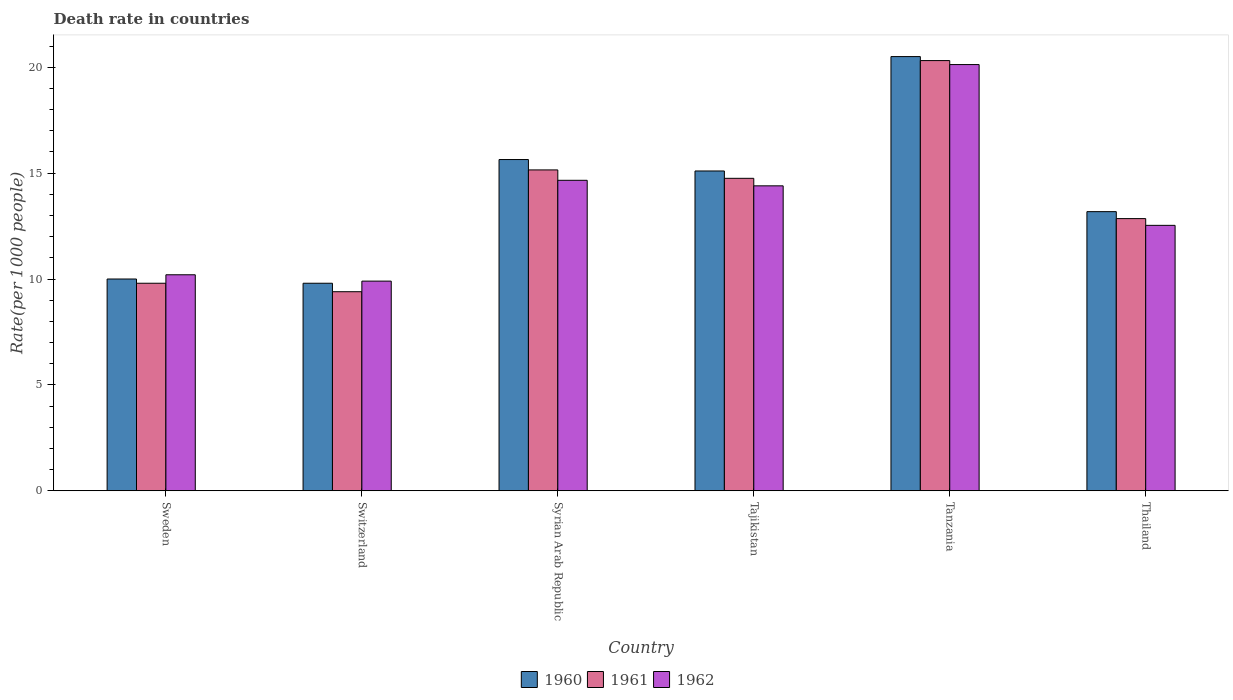Are the number of bars per tick equal to the number of legend labels?
Provide a succinct answer. Yes. Are the number of bars on each tick of the X-axis equal?
Provide a succinct answer. Yes. What is the label of the 2nd group of bars from the left?
Ensure brevity in your answer.  Switzerland. In how many cases, is the number of bars for a given country not equal to the number of legend labels?
Keep it short and to the point. 0. Across all countries, what is the maximum death rate in 1962?
Offer a terse response. 20.12. In which country was the death rate in 1962 maximum?
Your answer should be compact. Tanzania. In which country was the death rate in 1962 minimum?
Make the answer very short. Switzerland. What is the total death rate in 1960 in the graph?
Your answer should be compact. 84.22. What is the difference between the death rate in 1960 in Sweden and that in Thailand?
Keep it short and to the point. -3.18. What is the difference between the death rate in 1960 in Sweden and the death rate in 1961 in Switzerland?
Your answer should be very brief. 0.6. What is the average death rate in 1961 per country?
Make the answer very short. 13.71. What is the difference between the death rate of/in 1960 and death rate of/in 1962 in Syrian Arab Republic?
Your answer should be compact. 0.98. In how many countries, is the death rate in 1960 greater than 20?
Your answer should be very brief. 1. What is the ratio of the death rate in 1962 in Switzerland to that in Syrian Arab Republic?
Your response must be concise. 0.68. Is the death rate in 1960 in Switzerland less than that in Tanzania?
Ensure brevity in your answer.  Yes. Is the difference between the death rate in 1960 in Sweden and Tajikistan greater than the difference between the death rate in 1962 in Sweden and Tajikistan?
Provide a succinct answer. No. What is the difference between the highest and the second highest death rate in 1961?
Provide a succinct answer. 5.56. What is the difference between the highest and the lowest death rate in 1960?
Make the answer very short. 10.7. What does the 1st bar from the right in Tajikistan represents?
Provide a short and direct response. 1962. Is it the case that in every country, the sum of the death rate in 1960 and death rate in 1961 is greater than the death rate in 1962?
Make the answer very short. Yes. Are all the bars in the graph horizontal?
Offer a terse response. No. How many countries are there in the graph?
Keep it short and to the point. 6. How many legend labels are there?
Provide a short and direct response. 3. How are the legend labels stacked?
Ensure brevity in your answer.  Horizontal. What is the title of the graph?
Give a very brief answer. Death rate in countries. What is the label or title of the Y-axis?
Make the answer very short. Rate(per 1000 people). What is the Rate(per 1000 people) of 1960 in Sweden?
Keep it short and to the point. 10. What is the Rate(per 1000 people) of 1961 in Sweden?
Provide a short and direct response. 9.8. What is the Rate(per 1000 people) in 1961 in Switzerland?
Provide a succinct answer. 9.4. What is the Rate(per 1000 people) in 1962 in Switzerland?
Your response must be concise. 9.9. What is the Rate(per 1000 people) of 1960 in Syrian Arab Republic?
Provide a succinct answer. 15.64. What is the Rate(per 1000 people) in 1961 in Syrian Arab Republic?
Your answer should be very brief. 15.15. What is the Rate(per 1000 people) in 1962 in Syrian Arab Republic?
Keep it short and to the point. 14.66. What is the Rate(per 1000 people) in 1960 in Tajikistan?
Ensure brevity in your answer.  15.1. What is the Rate(per 1000 people) in 1961 in Tajikistan?
Keep it short and to the point. 14.75. What is the Rate(per 1000 people) of 1962 in Tajikistan?
Provide a succinct answer. 14.4. What is the Rate(per 1000 people) in 1960 in Tanzania?
Provide a short and direct response. 20.5. What is the Rate(per 1000 people) in 1961 in Tanzania?
Offer a very short reply. 20.31. What is the Rate(per 1000 people) in 1962 in Tanzania?
Give a very brief answer. 20.12. What is the Rate(per 1000 people) in 1960 in Thailand?
Make the answer very short. 13.18. What is the Rate(per 1000 people) in 1961 in Thailand?
Give a very brief answer. 12.85. What is the Rate(per 1000 people) in 1962 in Thailand?
Your response must be concise. 12.53. Across all countries, what is the maximum Rate(per 1000 people) of 1960?
Offer a terse response. 20.5. Across all countries, what is the maximum Rate(per 1000 people) in 1961?
Your response must be concise. 20.31. Across all countries, what is the maximum Rate(per 1000 people) in 1962?
Provide a succinct answer. 20.12. What is the total Rate(per 1000 people) of 1960 in the graph?
Your answer should be very brief. 84.22. What is the total Rate(per 1000 people) in 1961 in the graph?
Offer a very short reply. 82.27. What is the total Rate(per 1000 people) of 1962 in the graph?
Your response must be concise. 81.82. What is the difference between the Rate(per 1000 people) in 1961 in Sweden and that in Switzerland?
Keep it short and to the point. 0.4. What is the difference between the Rate(per 1000 people) of 1960 in Sweden and that in Syrian Arab Republic?
Give a very brief answer. -5.64. What is the difference between the Rate(per 1000 people) of 1961 in Sweden and that in Syrian Arab Republic?
Offer a very short reply. -5.35. What is the difference between the Rate(per 1000 people) of 1962 in Sweden and that in Syrian Arab Republic?
Provide a succinct answer. -4.46. What is the difference between the Rate(per 1000 people) in 1960 in Sweden and that in Tajikistan?
Your answer should be compact. -5.1. What is the difference between the Rate(per 1000 people) in 1961 in Sweden and that in Tajikistan?
Offer a very short reply. -4.95. What is the difference between the Rate(per 1000 people) in 1962 in Sweden and that in Tajikistan?
Keep it short and to the point. -4.2. What is the difference between the Rate(per 1000 people) of 1960 in Sweden and that in Tanzania?
Give a very brief answer. -10.5. What is the difference between the Rate(per 1000 people) in 1961 in Sweden and that in Tanzania?
Give a very brief answer. -10.51. What is the difference between the Rate(per 1000 people) in 1962 in Sweden and that in Tanzania?
Make the answer very short. -9.93. What is the difference between the Rate(per 1000 people) of 1960 in Sweden and that in Thailand?
Your answer should be very brief. -3.18. What is the difference between the Rate(per 1000 people) of 1961 in Sweden and that in Thailand?
Your answer should be compact. -3.05. What is the difference between the Rate(per 1000 people) in 1962 in Sweden and that in Thailand?
Your answer should be very brief. -2.33. What is the difference between the Rate(per 1000 people) of 1960 in Switzerland and that in Syrian Arab Republic?
Ensure brevity in your answer.  -5.84. What is the difference between the Rate(per 1000 people) of 1961 in Switzerland and that in Syrian Arab Republic?
Your answer should be very brief. -5.75. What is the difference between the Rate(per 1000 people) in 1962 in Switzerland and that in Syrian Arab Republic?
Your response must be concise. -4.76. What is the difference between the Rate(per 1000 people) in 1960 in Switzerland and that in Tajikistan?
Offer a terse response. -5.3. What is the difference between the Rate(per 1000 people) in 1961 in Switzerland and that in Tajikistan?
Ensure brevity in your answer.  -5.35. What is the difference between the Rate(per 1000 people) in 1962 in Switzerland and that in Tajikistan?
Your answer should be very brief. -4.5. What is the difference between the Rate(per 1000 people) in 1960 in Switzerland and that in Tanzania?
Offer a very short reply. -10.7. What is the difference between the Rate(per 1000 people) in 1961 in Switzerland and that in Tanzania?
Keep it short and to the point. -10.91. What is the difference between the Rate(per 1000 people) of 1962 in Switzerland and that in Tanzania?
Offer a terse response. -10.22. What is the difference between the Rate(per 1000 people) of 1960 in Switzerland and that in Thailand?
Give a very brief answer. -3.38. What is the difference between the Rate(per 1000 people) of 1961 in Switzerland and that in Thailand?
Give a very brief answer. -3.45. What is the difference between the Rate(per 1000 people) in 1962 in Switzerland and that in Thailand?
Make the answer very short. -2.63. What is the difference between the Rate(per 1000 people) in 1960 in Syrian Arab Republic and that in Tajikistan?
Provide a succinct answer. 0.54. What is the difference between the Rate(per 1000 people) in 1961 in Syrian Arab Republic and that in Tajikistan?
Your answer should be compact. 0.4. What is the difference between the Rate(per 1000 people) of 1962 in Syrian Arab Republic and that in Tajikistan?
Keep it short and to the point. 0.26. What is the difference between the Rate(per 1000 people) in 1960 in Syrian Arab Republic and that in Tanzania?
Your answer should be very brief. -4.86. What is the difference between the Rate(per 1000 people) in 1961 in Syrian Arab Republic and that in Tanzania?
Offer a terse response. -5.16. What is the difference between the Rate(per 1000 people) in 1962 in Syrian Arab Republic and that in Tanzania?
Your answer should be very brief. -5.46. What is the difference between the Rate(per 1000 people) of 1960 in Syrian Arab Republic and that in Thailand?
Offer a very short reply. 2.46. What is the difference between the Rate(per 1000 people) in 1961 in Syrian Arab Republic and that in Thailand?
Provide a short and direct response. 2.3. What is the difference between the Rate(per 1000 people) in 1962 in Syrian Arab Republic and that in Thailand?
Ensure brevity in your answer.  2.13. What is the difference between the Rate(per 1000 people) of 1960 in Tajikistan and that in Tanzania?
Ensure brevity in your answer.  -5.4. What is the difference between the Rate(per 1000 people) in 1961 in Tajikistan and that in Tanzania?
Offer a very short reply. -5.56. What is the difference between the Rate(per 1000 people) in 1962 in Tajikistan and that in Tanzania?
Your answer should be very brief. -5.73. What is the difference between the Rate(per 1000 people) of 1960 in Tajikistan and that in Thailand?
Provide a succinct answer. 1.92. What is the difference between the Rate(per 1000 people) in 1961 in Tajikistan and that in Thailand?
Offer a very short reply. 1.9. What is the difference between the Rate(per 1000 people) in 1962 in Tajikistan and that in Thailand?
Your answer should be compact. 1.87. What is the difference between the Rate(per 1000 people) of 1960 in Tanzania and that in Thailand?
Make the answer very short. 7.32. What is the difference between the Rate(per 1000 people) of 1961 in Tanzania and that in Thailand?
Make the answer very short. 7.46. What is the difference between the Rate(per 1000 people) of 1962 in Tanzania and that in Thailand?
Offer a very short reply. 7.59. What is the difference between the Rate(per 1000 people) of 1961 in Sweden and the Rate(per 1000 people) of 1962 in Switzerland?
Make the answer very short. -0.1. What is the difference between the Rate(per 1000 people) of 1960 in Sweden and the Rate(per 1000 people) of 1961 in Syrian Arab Republic?
Ensure brevity in your answer.  -5.15. What is the difference between the Rate(per 1000 people) of 1960 in Sweden and the Rate(per 1000 people) of 1962 in Syrian Arab Republic?
Offer a terse response. -4.66. What is the difference between the Rate(per 1000 people) of 1961 in Sweden and the Rate(per 1000 people) of 1962 in Syrian Arab Republic?
Your response must be concise. -4.86. What is the difference between the Rate(per 1000 people) in 1960 in Sweden and the Rate(per 1000 people) in 1961 in Tajikistan?
Make the answer very short. -4.75. What is the difference between the Rate(per 1000 people) of 1960 in Sweden and the Rate(per 1000 people) of 1962 in Tajikistan?
Provide a succinct answer. -4.4. What is the difference between the Rate(per 1000 people) of 1961 in Sweden and the Rate(per 1000 people) of 1962 in Tajikistan?
Give a very brief answer. -4.6. What is the difference between the Rate(per 1000 people) of 1960 in Sweden and the Rate(per 1000 people) of 1961 in Tanzania?
Keep it short and to the point. -10.31. What is the difference between the Rate(per 1000 people) of 1960 in Sweden and the Rate(per 1000 people) of 1962 in Tanzania?
Ensure brevity in your answer.  -10.12. What is the difference between the Rate(per 1000 people) in 1961 in Sweden and the Rate(per 1000 people) in 1962 in Tanzania?
Give a very brief answer. -10.32. What is the difference between the Rate(per 1000 people) of 1960 in Sweden and the Rate(per 1000 people) of 1961 in Thailand?
Provide a succinct answer. -2.85. What is the difference between the Rate(per 1000 people) in 1960 in Sweden and the Rate(per 1000 people) in 1962 in Thailand?
Offer a very short reply. -2.53. What is the difference between the Rate(per 1000 people) of 1961 in Sweden and the Rate(per 1000 people) of 1962 in Thailand?
Your answer should be compact. -2.73. What is the difference between the Rate(per 1000 people) in 1960 in Switzerland and the Rate(per 1000 people) in 1961 in Syrian Arab Republic?
Your response must be concise. -5.35. What is the difference between the Rate(per 1000 people) of 1960 in Switzerland and the Rate(per 1000 people) of 1962 in Syrian Arab Republic?
Your answer should be compact. -4.86. What is the difference between the Rate(per 1000 people) of 1961 in Switzerland and the Rate(per 1000 people) of 1962 in Syrian Arab Republic?
Make the answer very short. -5.26. What is the difference between the Rate(per 1000 people) of 1960 in Switzerland and the Rate(per 1000 people) of 1961 in Tajikistan?
Your response must be concise. -4.95. What is the difference between the Rate(per 1000 people) of 1960 in Switzerland and the Rate(per 1000 people) of 1962 in Tajikistan?
Give a very brief answer. -4.6. What is the difference between the Rate(per 1000 people) of 1961 in Switzerland and the Rate(per 1000 people) of 1962 in Tajikistan?
Offer a terse response. -5. What is the difference between the Rate(per 1000 people) in 1960 in Switzerland and the Rate(per 1000 people) in 1961 in Tanzania?
Your response must be concise. -10.51. What is the difference between the Rate(per 1000 people) of 1960 in Switzerland and the Rate(per 1000 people) of 1962 in Tanzania?
Ensure brevity in your answer.  -10.32. What is the difference between the Rate(per 1000 people) in 1961 in Switzerland and the Rate(per 1000 people) in 1962 in Tanzania?
Offer a terse response. -10.72. What is the difference between the Rate(per 1000 people) in 1960 in Switzerland and the Rate(per 1000 people) in 1961 in Thailand?
Offer a terse response. -3.05. What is the difference between the Rate(per 1000 people) in 1960 in Switzerland and the Rate(per 1000 people) in 1962 in Thailand?
Provide a short and direct response. -2.73. What is the difference between the Rate(per 1000 people) in 1961 in Switzerland and the Rate(per 1000 people) in 1962 in Thailand?
Keep it short and to the point. -3.13. What is the difference between the Rate(per 1000 people) of 1960 in Syrian Arab Republic and the Rate(per 1000 people) of 1961 in Tajikistan?
Give a very brief answer. 0.89. What is the difference between the Rate(per 1000 people) in 1960 in Syrian Arab Republic and the Rate(per 1000 people) in 1962 in Tajikistan?
Make the answer very short. 1.24. What is the difference between the Rate(per 1000 people) of 1961 in Syrian Arab Republic and the Rate(per 1000 people) of 1962 in Tajikistan?
Ensure brevity in your answer.  0.75. What is the difference between the Rate(per 1000 people) of 1960 in Syrian Arab Republic and the Rate(per 1000 people) of 1961 in Tanzania?
Keep it short and to the point. -4.67. What is the difference between the Rate(per 1000 people) of 1960 in Syrian Arab Republic and the Rate(per 1000 people) of 1962 in Tanzania?
Provide a succinct answer. -4.48. What is the difference between the Rate(per 1000 people) in 1961 in Syrian Arab Republic and the Rate(per 1000 people) in 1962 in Tanzania?
Offer a terse response. -4.97. What is the difference between the Rate(per 1000 people) of 1960 in Syrian Arab Republic and the Rate(per 1000 people) of 1961 in Thailand?
Your answer should be compact. 2.79. What is the difference between the Rate(per 1000 people) of 1960 in Syrian Arab Republic and the Rate(per 1000 people) of 1962 in Thailand?
Keep it short and to the point. 3.11. What is the difference between the Rate(per 1000 people) of 1961 in Syrian Arab Republic and the Rate(per 1000 people) of 1962 in Thailand?
Your response must be concise. 2.62. What is the difference between the Rate(per 1000 people) of 1960 in Tajikistan and the Rate(per 1000 people) of 1961 in Tanzania?
Give a very brief answer. -5.21. What is the difference between the Rate(per 1000 people) in 1960 in Tajikistan and the Rate(per 1000 people) in 1962 in Tanzania?
Provide a succinct answer. -5.02. What is the difference between the Rate(per 1000 people) of 1961 in Tajikistan and the Rate(per 1000 people) of 1962 in Tanzania?
Your answer should be very brief. -5.37. What is the difference between the Rate(per 1000 people) in 1960 in Tajikistan and the Rate(per 1000 people) in 1961 in Thailand?
Your answer should be compact. 2.25. What is the difference between the Rate(per 1000 people) of 1960 in Tajikistan and the Rate(per 1000 people) of 1962 in Thailand?
Give a very brief answer. 2.57. What is the difference between the Rate(per 1000 people) in 1961 in Tajikistan and the Rate(per 1000 people) in 1962 in Thailand?
Give a very brief answer. 2.22. What is the difference between the Rate(per 1000 people) in 1960 in Tanzania and the Rate(per 1000 people) in 1961 in Thailand?
Provide a succinct answer. 7.65. What is the difference between the Rate(per 1000 people) of 1960 in Tanzania and the Rate(per 1000 people) of 1962 in Thailand?
Your answer should be very brief. 7.97. What is the difference between the Rate(per 1000 people) in 1961 in Tanzania and the Rate(per 1000 people) in 1962 in Thailand?
Ensure brevity in your answer.  7.78. What is the average Rate(per 1000 people) of 1960 per country?
Keep it short and to the point. 14.04. What is the average Rate(per 1000 people) in 1961 per country?
Provide a short and direct response. 13.71. What is the average Rate(per 1000 people) in 1962 per country?
Provide a short and direct response. 13.64. What is the difference between the Rate(per 1000 people) of 1960 and Rate(per 1000 people) of 1961 in Sweden?
Ensure brevity in your answer.  0.2. What is the difference between the Rate(per 1000 people) in 1961 and Rate(per 1000 people) in 1962 in Sweden?
Keep it short and to the point. -0.4. What is the difference between the Rate(per 1000 people) in 1960 and Rate(per 1000 people) in 1962 in Switzerland?
Your answer should be very brief. -0.1. What is the difference between the Rate(per 1000 people) of 1961 and Rate(per 1000 people) of 1962 in Switzerland?
Ensure brevity in your answer.  -0.5. What is the difference between the Rate(per 1000 people) of 1960 and Rate(per 1000 people) of 1961 in Syrian Arab Republic?
Give a very brief answer. 0.49. What is the difference between the Rate(per 1000 people) in 1960 and Rate(per 1000 people) in 1962 in Syrian Arab Republic?
Offer a very short reply. 0.98. What is the difference between the Rate(per 1000 people) of 1961 and Rate(per 1000 people) of 1962 in Syrian Arab Republic?
Your answer should be very brief. 0.49. What is the difference between the Rate(per 1000 people) in 1960 and Rate(per 1000 people) in 1961 in Tajikistan?
Provide a succinct answer. 0.35. What is the difference between the Rate(per 1000 people) of 1960 and Rate(per 1000 people) of 1962 in Tajikistan?
Your answer should be very brief. 0.7. What is the difference between the Rate(per 1000 people) in 1961 and Rate(per 1000 people) in 1962 in Tajikistan?
Give a very brief answer. 0.35. What is the difference between the Rate(per 1000 people) of 1960 and Rate(per 1000 people) of 1961 in Tanzania?
Make the answer very short. 0.19. What is the difference between the Rate(per 1000 people) of 1960 and Rate(per 1000 people) of 1962 in Tanzania?
Your answer should be compact. 0.38. What is the difference between the Rate(per 1000 people) of 1961 and Rate(per 1000 people) of 1962 in Tanzania?
Give a very brief answer. 0.19. What is the difference between the Rate(per 1000 people) in 1960 and Rate(per 1000 people) in 1961 in Thailand?
Offer a terse response. 0.33. What is the difference between the Rate(per 1000 people) in 1960 and Rate(per 1000 people) in 1962 in Thailand?
Keep it short and to the point. 0.65. What is the difference between the Rate(per 1000 people) in 1961 and Rate(per 1000 people) in 1962 in Thailand?
Your response must be concise. 0.32. What is the ratio of the Rate(per 1000 people) of 1960 in Sweden to that in Switzerland?
Keep it short and to the point. 1.02. What is the ratio of the Rate(per 1000 people) in 1961 in Sweden to that in Switzerland?
Offer a terse response. 1.04. What is the ratio of the Rate(per 1000 people) in 1962 in Sweden to that in Switzerland?
Keep it short and to the point. 1.03. What is the ratio of the Rate(per 1000 people) in 1960 in Sweden to that in Syrian Arab Republic?
Provide a succinct answer. 0.64. What is the ratio of the Rate(per 1000 people) of 1961 in Sweden to that in Syrian Arab Republic?
Give a very brief answer. 0.65. What is the ratio of the Rate(per 1000 people) of 1962 in Sweden to that in Syrian Arab Republic?
Offer a terse response. 0.7. What is the ratio of the Rate(per 1000 people) of 1960 in Sweden to that in Tajikistan?
Offer a very short reply. 0.66. What is the ratio of the Rate(per 1000 people) in 1961 in Sweden to that in Tajikistan?
Ensure brevity in your answer.  0.66. What is the ratio of the Rate(per 1000 people) of 1962 in Sweden to that in Tajikistan?
Make the answer very short. 0.71. What is the ratio of the Rate(per 1000 people) in 1960 in Sweden to that in Tanzania?
Your answer should be very brief. 0.49. What is the ratio of the Rate(per 1000 people) of 1961 in Sweden to that in Tanzania?
Make the answer very short. 0.48. What is the ratio of the Rate(per 1000 people) of 1962 in Sweden to that in Tanzania?
Provide a succinct answer. 0.51. What is the ratio of the Rate(per 1000 people) of 1960 in Sweden to that in Thailand?
Your answer should be compact. 0.76. What is the ratio of the Rate(per 1000 people) in 1961 in Sweden to that in Thailand?
Provide a succinct answer. 0.76. What is the ratio of the Rate(per 1000 people) in 1962 in Sweden to that in Thailand?
Make the answer very short. 0.81. What is the ratio of the Rate(per 1000 people) of 1960 in Switzerland to that in Syrian Arab Republic?
Make the answer very short. 0.63. What is the ratio of the Rate(per 1000 people) of 1961 in Switzerland to that in Syrian Arab Republic?
Your answer should be very brief. 0.62. What is the ratio of the Rate(per 1000 people) of 1962 in Switzerland to that in Syrian Arab Republic?
Your answer should be very brief. 0.68. What is the ratio of the Rate(per 1000 people) in 1960 in Switzerland to that in Tajikistan?
Offer a terse response. 0.65. What is the ratio of the Rate(per 1000 people) of 1961 in Switzerland to that in Tajikistan?
Your answer should be compact. 0.64. What is the ratio of the Rate(per 1000 people) of 1962 in Switzerland to that in Tajikistan?
Provide a succinct answer. 0.69. What is the ratio of the Rate(per 1000 people) in 1960 in Switzerland to that in Tanzania?
Offer a very short reply. 0.48. What is the ratio of the Rate(per 1000 people) of 1961 in Switzerland to that in Tanzania?
Your answer should be compact. 0.46. What is the ratio of the Rate(per 1000 people) of 1962 in Switzerland to that in Tanzania?
Give a very brief answer. 0.49. What is the ratio of the Rate(per 1000 people) of 1960 in Switzerland to that in Thailand?
Provide a succinct answer. 0.74. What is the ratio of the Rate(per 1000 people) of 1961 in Switzerland to that in Thailand?
Your answer should be very brief. 0.73. What is the ratio of the Rate(per 1000 people) of 1962 in Switzerland to that in Thailand?
Offer a terse response. 0.79. What is the ratio of the Rate(per 1000 people) in 1960 in Syrian Arab Republic to that in Tajikistan?
Keep it short and to the point. 1.04. What is the ratio of the Rate(per 1000 people) in 1961 in Syrian Arab Republic to that in Tajikistan?
Your answer should be very brief. 1.03. What is the ratio of the Rate(per 1000 people) in 1962 in Syrian Arab Republic to that in Tajikistan?
Offer a very short reply. 1.02. What is the ratio of the Rate(per 1000 people) of 1960 in Syrian Arab Republic to that in Tanzania?
Make the answer very short. 0.76. What is the ratio of the Rate(per 1000 people) in 1961 in Syrian Arab Republic to that in Tanzania?
Your answer should be very brief. 0.75. What is the ratio of the Rate(per 1000 people) in 1962 in Syrian Arab Republic to that in Tanzania?
Offer a terse response. 0.73. What is the ratio of the Rate(per 1000 people) of 1960 in Syrian Arab Republic to that in Thailand?
Keep it short and to the point. 1.19. What is the ratio of the Rate(per 1000 people) of 1961 in Syrian Arab Republic to that in Thailand?
Offer a very short reply. 1.18. What is the ratio of the Rate(per 1000 people) in 1962 in Syrian Arab Republic to that in Thailand?
Keep it short and to the point. 1.17. What is the ratio of the Rate(per 1000 people) of 1960 in Tajikistan to that in Tanzania?
Ensure brevity in your answer.  0.74. What is the ratio of the Rate(per 1000 people) in 1961 in Tajikistan to that in Tanzania?
Give a very brief answer. 0.73. What is the ratio of the Rate(per 1000 people) in 1962 in Tajikistan to that in Tanzania?
Your answer should be compact. 0.72. What is the ratio of the Rate(per 1000 people) in 1960 in Tajikistan to that in Thailand?
Offer a very short reply. 1.15. What is the ratio of the Rate(per 1000 people) of 1961 in Tajikistan to that in Thailand?
Provide a succinct answer. 1.15. What is the ratio of the Rate(per 1000 people) of 1962 in Tajikistan to that in Thailand?
Keep it short and to the point. 1.15. What is the ratio of the Rate(per 1000 people) of 1960 in Tanzania to that in Thailand?
Your answer should be very brief. 1.56. What is the ratio of the Rate(per 1000 people) in 1961 in Tanzania to that in Thailand?
Offer a very short reply. 1.58. What is the ratio of the Rate(per 1000 people) in 1962 in Tanzania to that in Thailand?
Provide a short and direct response. 1.61. What is the difference between the highest and the second highest Rate(per 1000 people) in 1960?
Ensure brevity in your answer.  4.86. What is the difference between the highest and the second highest Rate(per 1000 people) of 1961?
Keep it short and to the point. 5.16. What is the difference between the highest and the second highest Rate(per 1000 people) of 1962?
Provide a short and direct response. 5.46. What is the difference between the highest and the lowest Rate(per 1000 people) in 1960?
Provide a short and direct response. 10.7. What is the difference between the highest and the lowest Rate(per 1000 people) of 1961?
Keep it short and to the point. 10.91. What is the difference between the highest and the lowest Rate(per 1000 people) in 1962?
Provide a short and direct response. 10.22. 